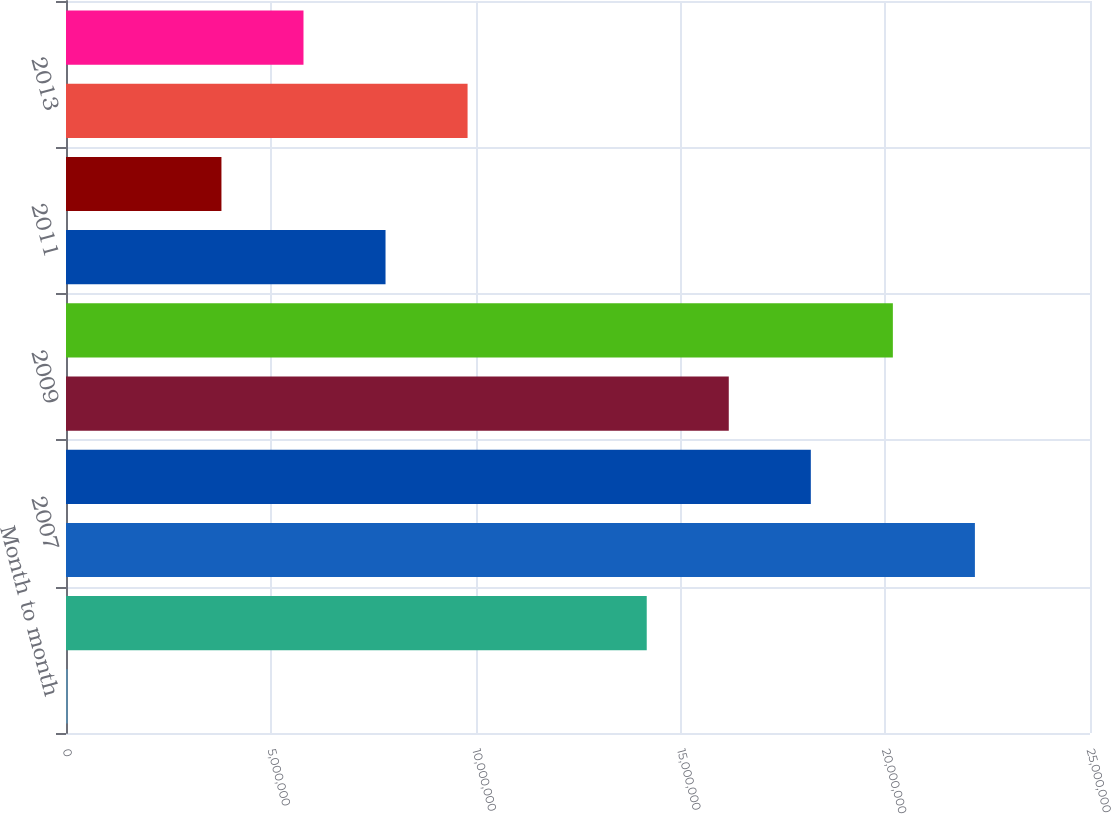Convert chart to OTSL. <chart><loc_0><loc_0><loc_500><loc_500><bar_chart><fcel>Month to month<fcel>2006<fcel>2007<fcel>2008<fcel>2009<fcel>2010<fcel>2011<fcel>2012<fcel>2013<fcel>2014<nl><fcel>46000<fcel>1.4178e+07<fcel>2.219e+07<fcel>1.8184e+07<fcel>1.6181e+07<fcel>2.0187e+07<fcel>7.801e+06<fcel>3.795e+06<fcel>9.804e+06<fcel>5.798e+06<nl></chart> 